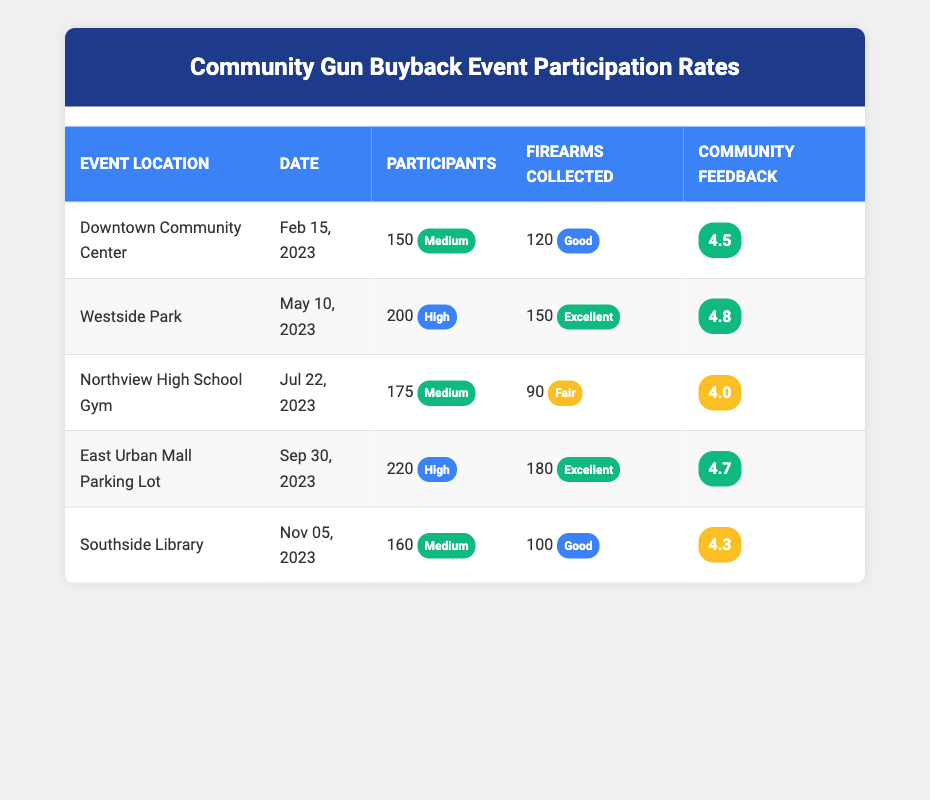What was the location of the event with the highest community feedback score? The highest community feedback score listed in the table is 4.8, which corresponds to the event held at Westside Park on May 10, 2023.
Answer: Westside Park How many firearms were collected at the Downtown Community Center event? According to the table, the firearms collected at the Downtown Community Center event was 120.
Answer: 120 Which event had the lowest participation count? The event with the lowest participation count is the Downtown Community Center event with 150 participants.
Answer: 150 What is the average participation count across all events? To find the average participation count, we add the participation counts (150 + 200 + 175 + 220 + 160) = 905 and then divide by the number of events (5). So, the average is 905/5 = 181.
Answer: 181 Did any event collect more firearms than participants? Yes, the East Urban Mall Parking Lot event had 220 participants and collected 180 firearms, meaning it did collect slightly fewer than the number of participants.
Answer: No Which event followed the Northview High School Gym in terms of feedback score? The Northview High School Gym event has a feedback score of 4.0. The next event, Southside Library, has a feedback score of 4.3, which is higher than Northview. Therefore, it follows in terms of feedback score.
Answer: Southside Library What was the total number of firearms collected across all events? The total number of firearms collected is found by summing up each event's firearm count (120 + 150 + 90 + 180 + 100) = 640.
Answer: 640 What percentage of participants at the East Urban Mall Parking Lot event returned firearms? The percentage is calculated by taking the number of firearms collected (180) and dividing it by the participation count (220), then multiplying by 100. (180/220) * 100 = 81.82%.
Answer: 81.82% 